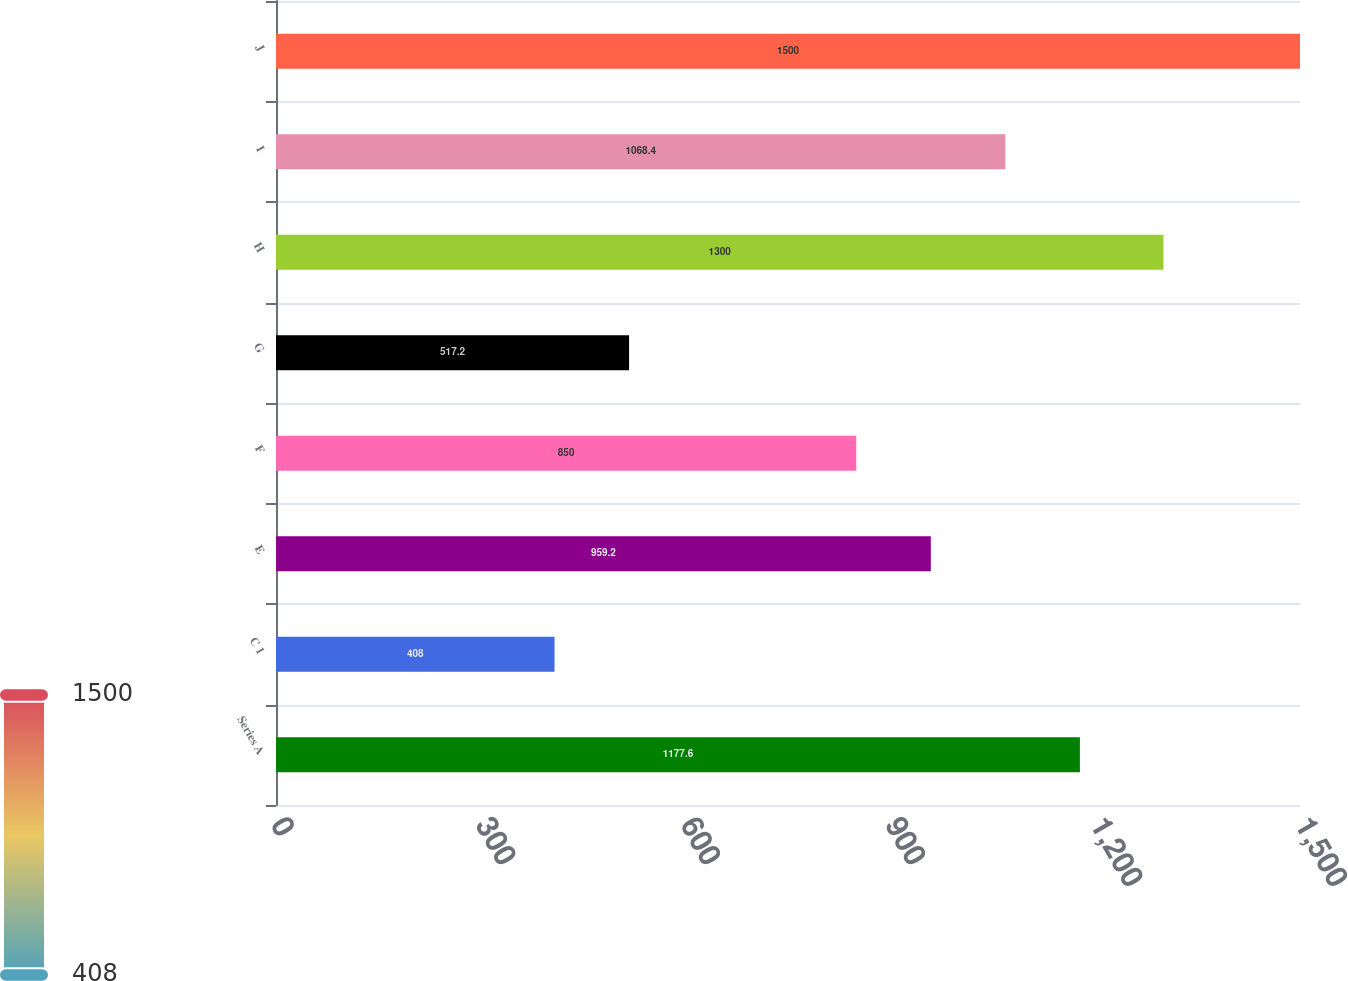Convert chart. <chart><loc_0><loc_0><loc_500><loc_500><bar_chart><fcel>Series A<fcel>C 1<fcel>E<fcel>F<fcel>G<fcel>H<fcel>I<fcel>J<nl><fcel>1177.6<fcel>408<fcel>959.2<fcel>850<fcel>517.2<fcel>1300<fcel>1068.4<fcel>1500<nl></chart> 